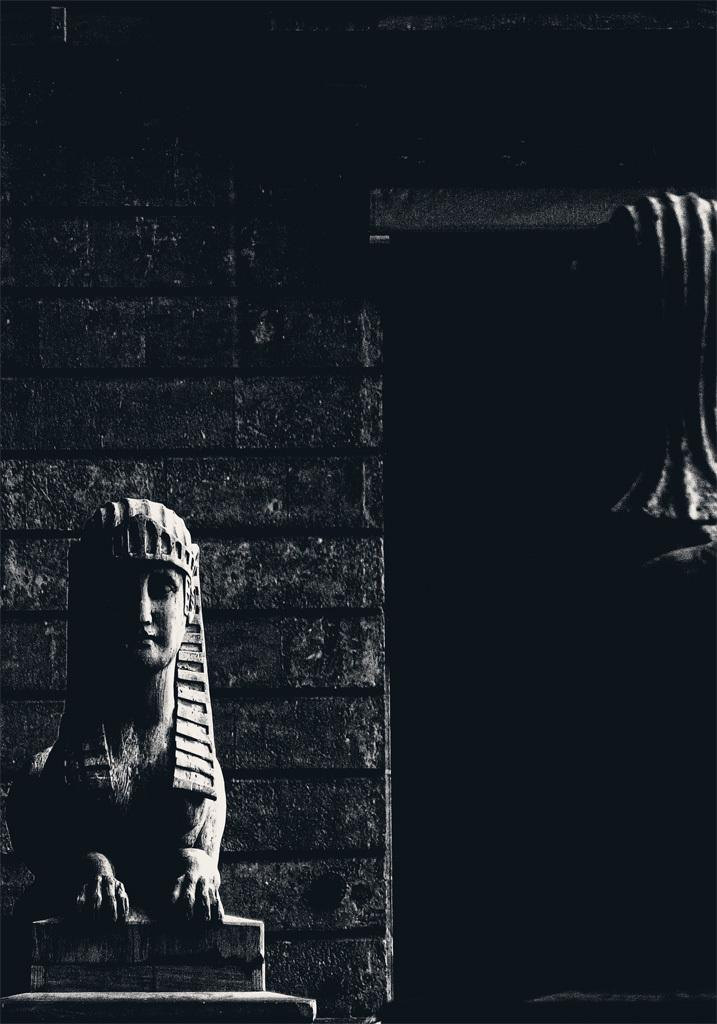What is the color scheme of the image? The image is black and white. What is the main subject in the image? There is a statue in the image. How is the statue positioned in the image? The statue is on a pedestal. What can be seen in the background of the image? There is a brick wall in the background of the image. What type of stocking is the statue wearing in the image? There is no stocking present on the statue in the image, as it is a statue and not a person. What message of peace is conveyed by the statue in the image? The image does not convey a message of peace, as there is no context provided for the statue's meaning or purpose. 